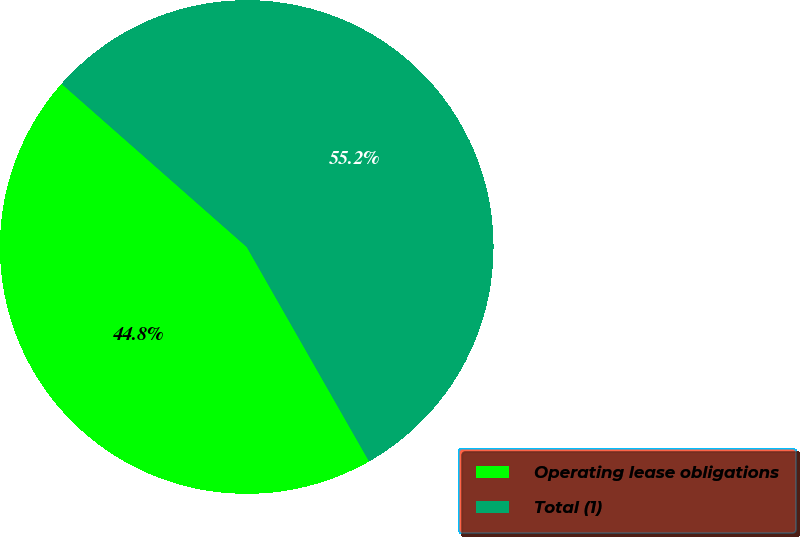Convert chart. <chart><loc_0><loc_0><loc_500><loc_500><pie_chart><fcel>Operating lease obligations<fcel>Total (1)<nl><fcel>44.75%<fcel>55.25%<nl></chart> 